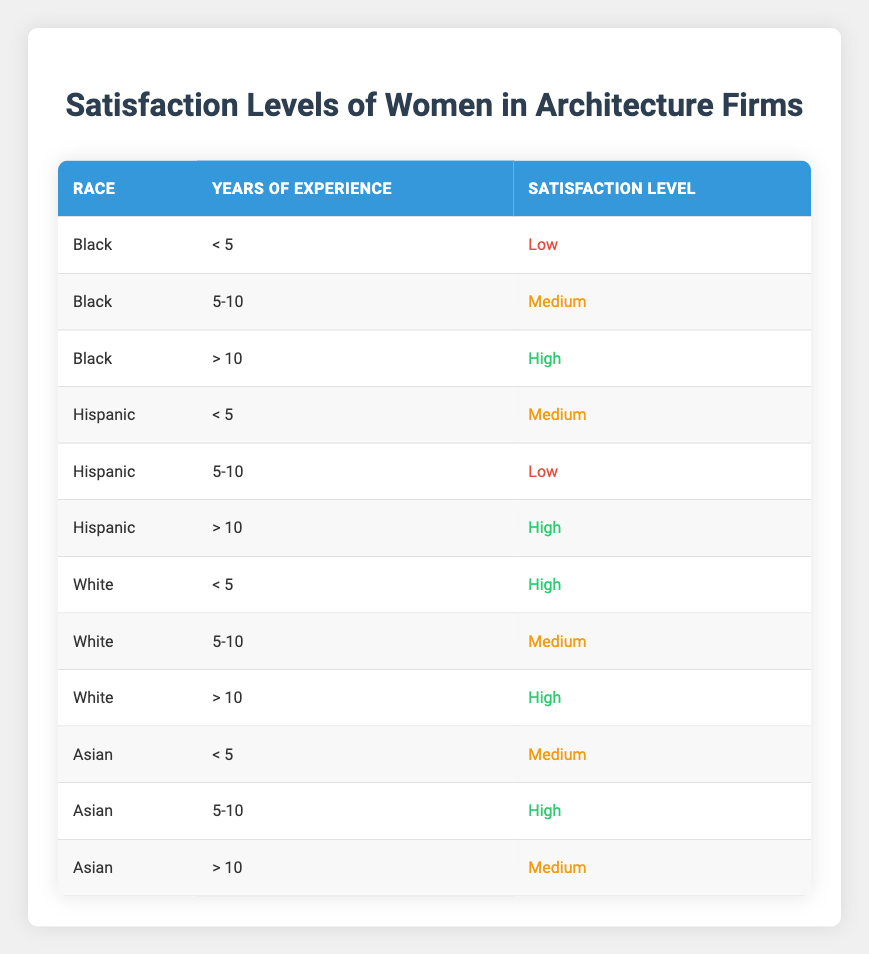What is the satisfaction level of Black women with over 10 years of experience? According to the table, for Black women with over 10 years of experience, the satisfaction level is "High."
Answer: High How many satisfaction levels are recorded for Hispanic women with less than 5 years of experience? There is one satisfaction level recorded for Hispanic women with less than 5 years of experience, which is "Medium."
Answer: 1 Are Hispanic women with 5-10 years of experience more satisfied than Black women with the same years of experience? Hispanic women with 5-10 years of experience have a satisfaction level of "Low," while Black women with the same level of experience have a satisfaction level of "Medium." Therefore, Black women are more satisfied.
Answer: No What is the average satisfaction level for Asian women across all years of experience? For Asian women: less than 5 years = Medium, 5-10 years = High, and more than 10 years = Medium. Converting these to a numerical scale: Medium = 2, High = 3. The average is (2 + 3 + 2)/3 = 2.33.
Answer: Approximately 2.33 Is there a category for Black women with low satisfaction? Yes, the table indicates that Black women with less than 5 years of experience have a satisfaction level classified as "Low."
Answer: Yes What is the highest satisfaction level recorded for any race in the under 5 years of experience category? The highest satisfaction level in the under 5 years of experience category is "High," observed for White women.
Answer: High List the races with "High" satisfaction levels for women with more than 10 years of experience. The races with "High" satisfaction levels for women with more than 10 years of experience are Black, Hispanic, and White.
Answer: Black, Hispanic, White Are there any satisfaction levels considered "Medium" for women with over 10 years of experience? No, the table indicates that all races with over 10 years of experience report satisfaction levels as either "High" or "Low," making it impossible for "Medium" to be a reported satisfaction level.
Answer: No 